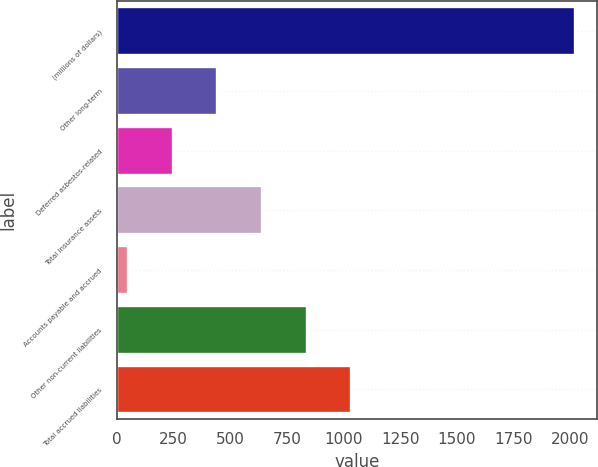<chart> <loc_0><loc_0><loc_500><loc_500><bar_chart><fcel>(millions of dollars)<fcel>Other long-term<fcel>Deferred asbestos-related<fcel>Total insurance assets<fcel>Accounts payable and accrued<fcel>Other non-current liabilities<fcel>Total accrued liabilities<nl><fcel>2018<fcel>443.6<fcel>246.8<fcel>640.4<fcel>50<fcel>837.2<fcel>1034<nl></chart> 